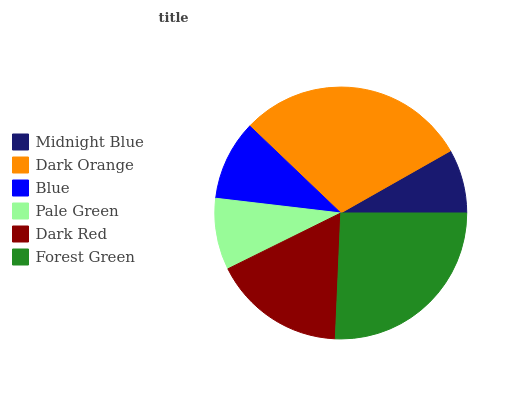Is Midnight Blue the minimum?
Answer yes or no. Yes. Is Dark Orange the maximum?
Answer yes or no. Yes. Is Blue the minimum?
Answer yes or no. No. Is Blue the maximum?
Answer yes or no. No. Is Dark Orange greater than Blue?
Answer yes or no. Yes. Is Blue less than Dark Orange?
Answer yes or no. Yes. Is Blue greater than Dark Orange?
Answer yes or no. No. Is Dark Orange less than Blue?
Answer yes or no. No. Is Dark Red the high median?
Answer yes or no. Yes. Is Blue the low median?
Answer yes or no. Yes. Is Pale Green the high median?
Answer yes or no. No. Is Midnight Blue the low median?
Answer yes or no. No. 